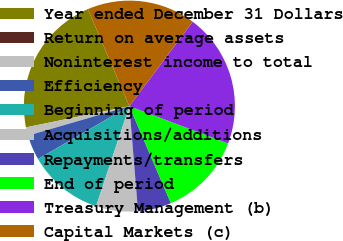<chart> <loc_0><loc_0><loc_500><loc_500><pie_chart><fcel>Year ended December 31 Dollars<fcel>Return on average assets<fcel>Noninterest income to total<fcel>Efficiency<fcel>Beginning of period<fcel>Acquisitions/additions<fcel>Repayments/transfers<fcel>End of period<fcel>Treasury Management (b)<fcel>Capital Markets (c)<nl><fcel>21.79%<fcel>0.0%<fcel>1.28%<fcel>3.85%<fcel>11.54%<fcel>6.41%<fcel>5.13%<fcel>12.82%<fcel>20.51%<fcel>16.67%<nl></chart> 